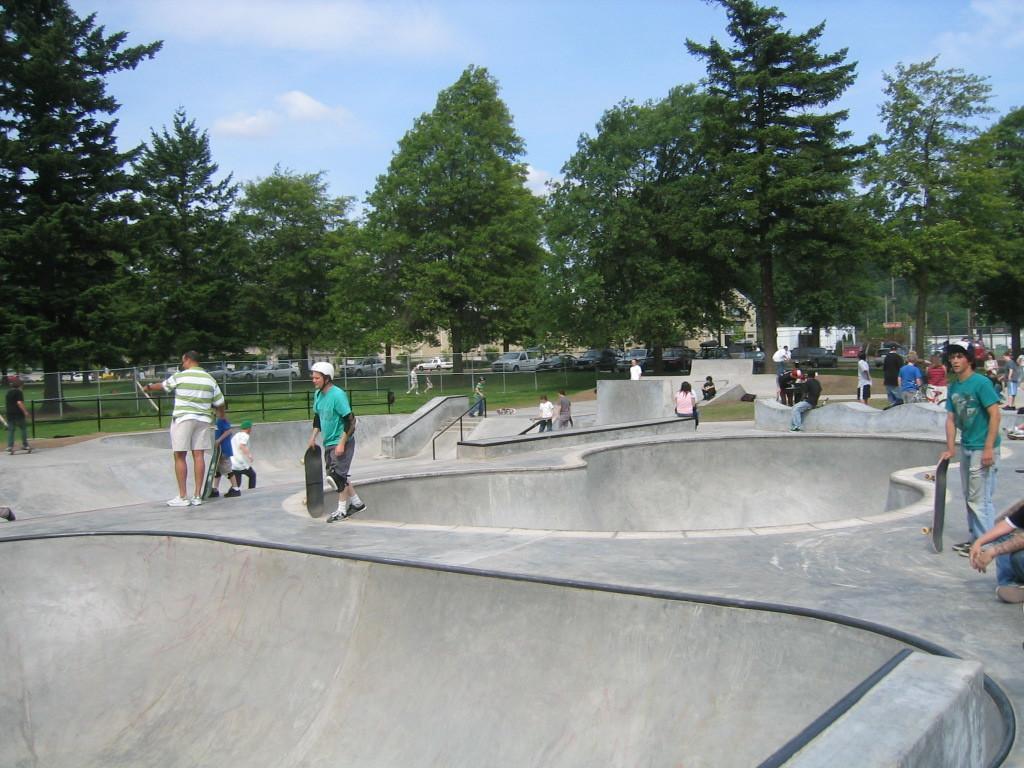How would you summarize this image in a sentence or two? In this image there are some persons standing and holding the skate board and also some persons sitting on the ground. And few persons sitting on the constructed wall. In the background there is a black color and also a white color fence. Image also consists of many cars and trees. At the top there is sky with some clouds. 